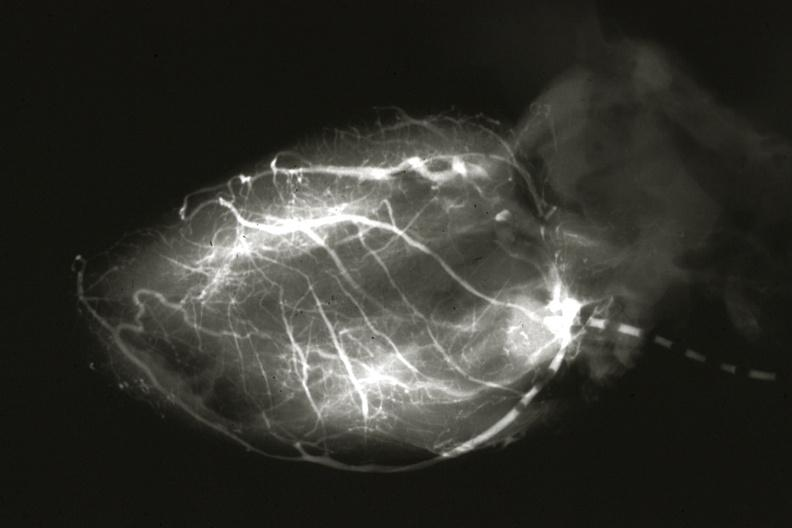s coronary artery anomalous origin left from pulmonary artery present?
Answer the question using a single word or phrase. Yes 